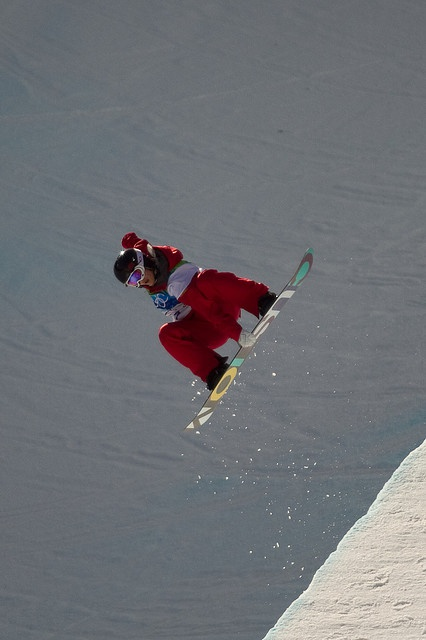Describe the objects in this image and their specific colors. I can see people in gray, maroon, and black tones and snowboard in gray, darkgray, teal, and tan tones in this image. 